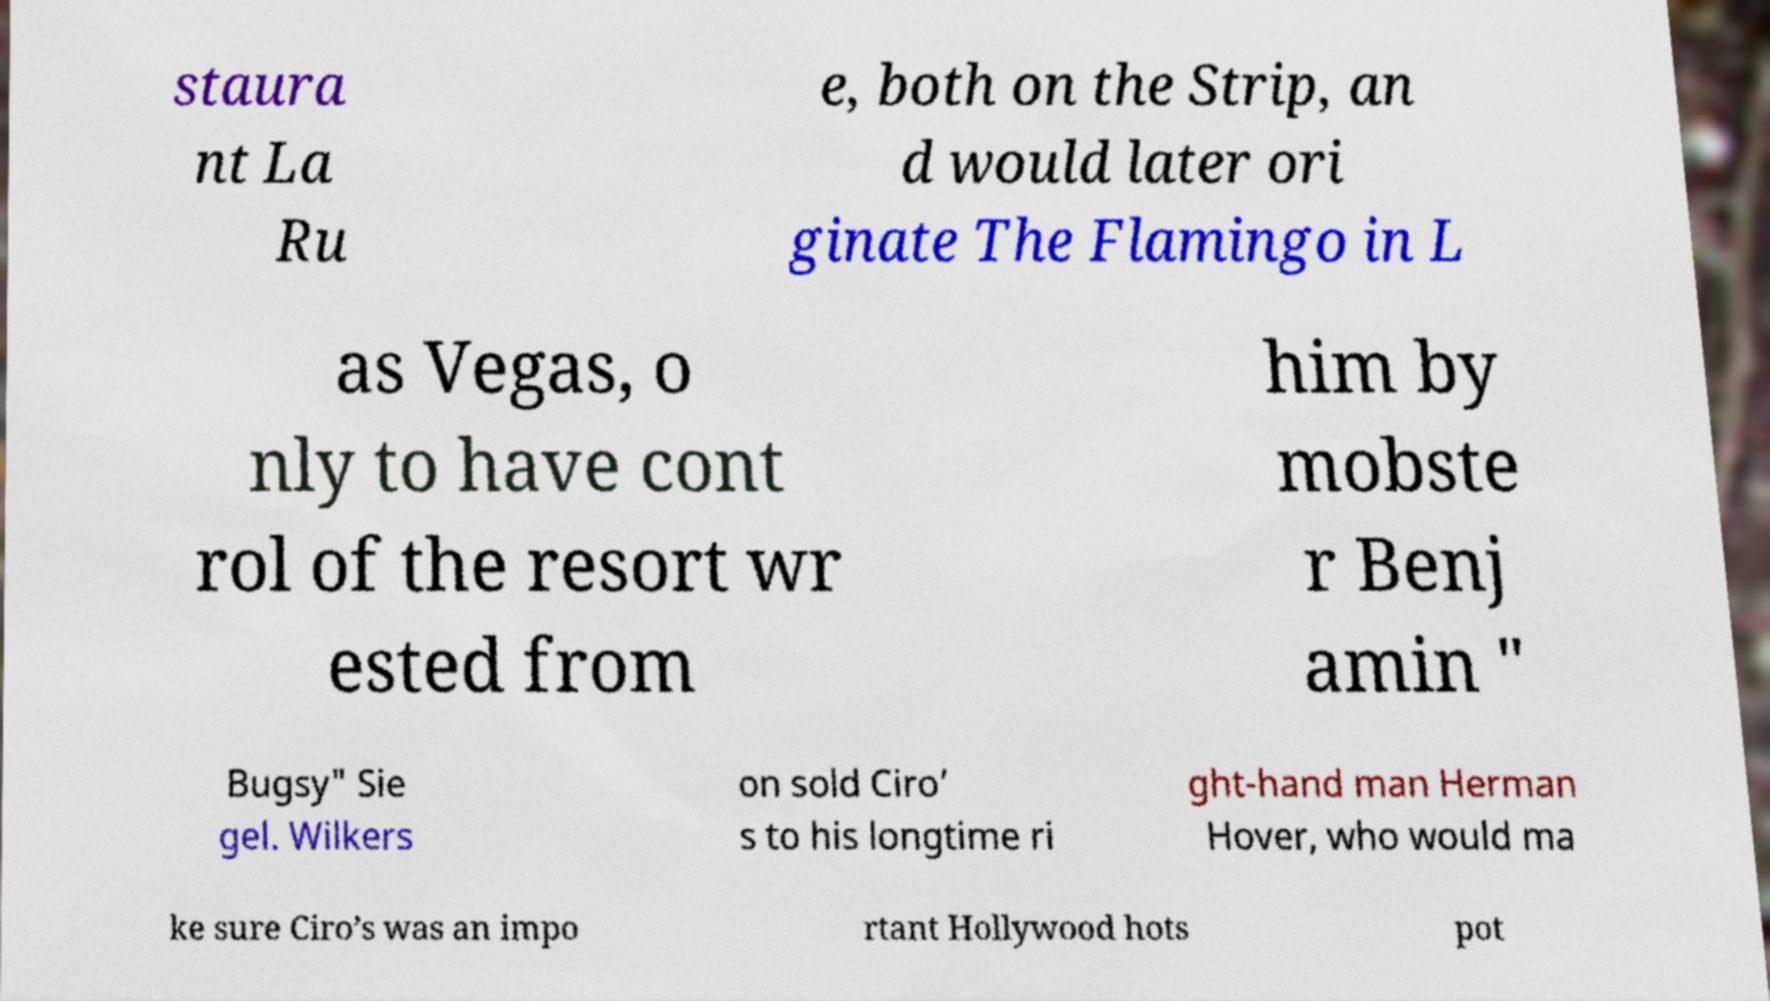What messages or text are displayed in this image? I need them in a readable, typed format. staura nt La Ru e, both on the Strip, an d would later ori ginate The Flamingo in L as Vegas, o nly to have cont rol of the resort wr ested from him by mobste r Benj amin " Bugsy" Sie gel. Wilkers on sold Ciro’ s to his longtime ri ght-hand man Herman Hover, who would ma ke sure Ciro’s was an impo rtant Hollywood hots pot 